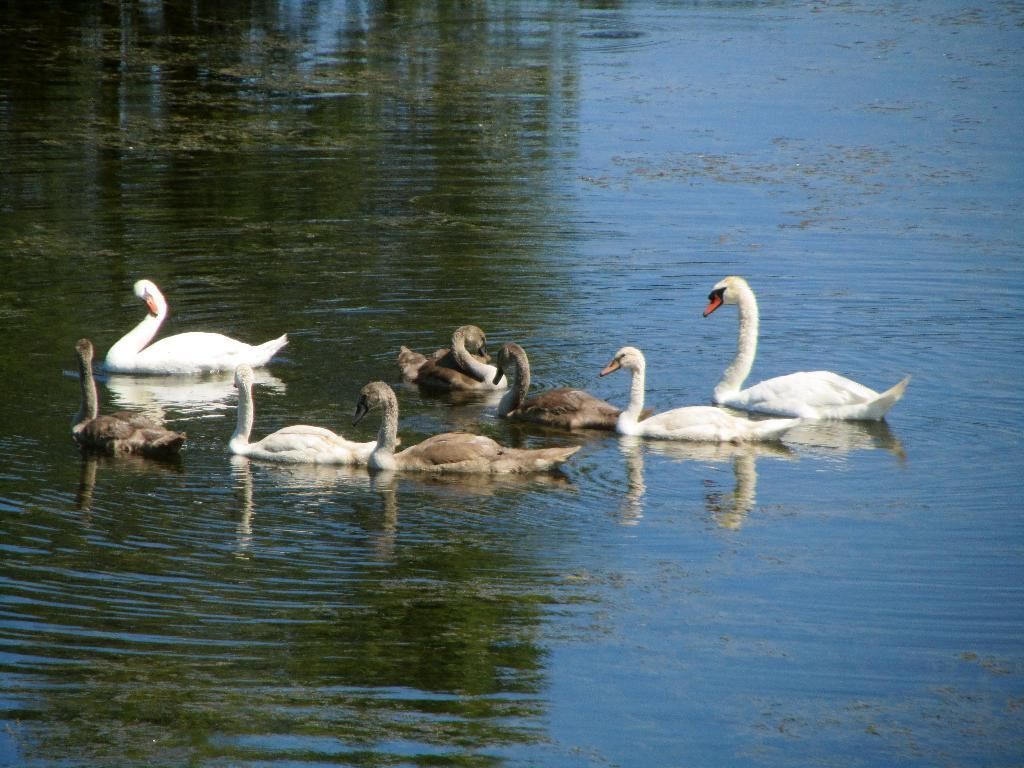Where was the image taken? The image was taken outdoors. What can be seen at the bottom of the image? There is a pond with water at the bottom of the image. What animals are present in the pond? There are a few ducks swimming in the pond in the middle of the image. Can you see a girl holding a hen and a kitten in the image? No, there is no girl, hen, or kitten present in the image. The image only features a pond with ducks swimming in it. 